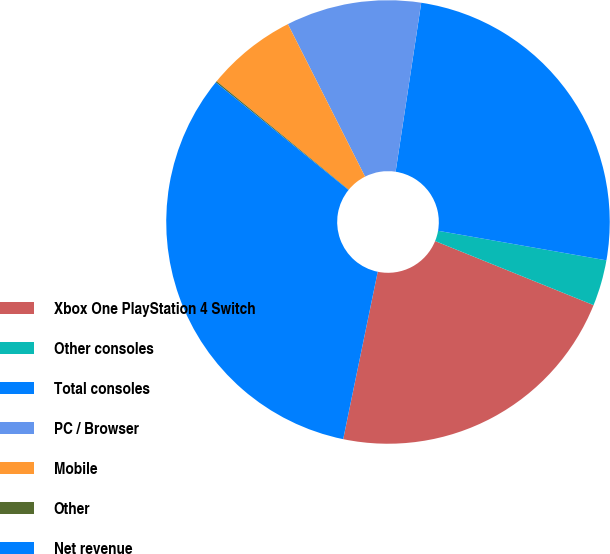<chart> <loc_0><loc_0><loc_500><loc_500><pie_chart><fcel>Xbox One PlayStation 4 Switch<fcel>Other consoles<fcel>Total consoles<fcel>PC / Browser<fcel>Mobile<fcel>Other<fcel>Net revenue<nl><fcel>22.12%<fcel>3.35%<fcel>25.37%<fcel>9.85%<fcel>6.6%<fcel>0.1%<fcel>32.6%<nl></chart> 